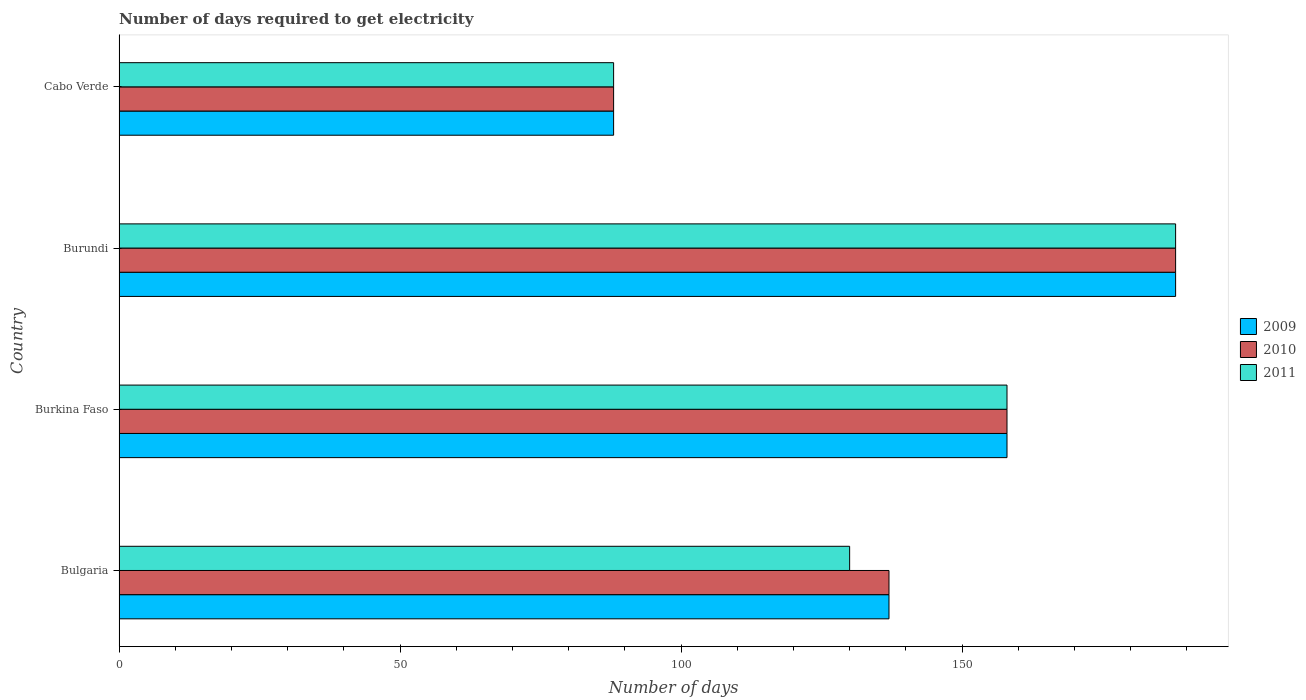How many different coloured bars are there?
Give a very brief answer. 3. What is the label of the 2nd group of bars from the top?
Your response must be concise. Burundi. What is the number of days required to get electricity in in 2010 in Burundi?
Your response must be concise. 188. Across all countries, what is the maximum number of days required to get electricity in in 2011?
Your answer should be compact. 188. Across all countries, what is the minimum number of days required to get electricity in in 2010?
Your answer should be compact. 88. In which country was the number of days required to get electricity in in 2009 maximum?
Make the answer very short. Burundi. In which country was the number of days required to get electricity in in 2011 minimum?
Provide a short and direct response. Cabo Verde. What is the total number of days required to get electricity in in 2009 in the graph?
Your answer should be very brief. 571. What is the difference between the number of days required to get electricity in in 2010 in Bulgaria and that in Cabo Verde?
Your response must be concise. 49. What is the average number of days required to get electricity in in 2011 per country?
Offer a very short reply. 141. What is the ratio of the number of days required to get electricity in in 2011 in Bulgaria to that in Cabo Verde?
Offer a very short reply. 1.48. What is the difference between the highest and the second highest number of days required to get electricity in in 2009?
Your answer should be compact. 30. What is the difference between the highest and the lowest number of days required to get electricity in in 2011?
Your answer should be compact. 100. Is the sum of the number of days required to get electricity in in 2011 in Burundi and Cabo Verde greater than the maximum number of days required to get electricity in in 2010 across all countries?
Provide a short and direct response. Yes. Is it the case that in every country, the sum of the number of days required to get electricity in in 2009 and number of days required to get electricity in in 2010 is greater than the number of days required to get electricity in in 2011?
Ensure brevity in your answer.  Yes. Are all the bars in the graph horizontal?
Ensure brevity in your answer.  Yes. How many countries are there in the graph?
Provide a succinct answer. 4. What is the difference between two consecutive major ticks on the X-axis?
Your answer should be compact. 50. Are the values on the major ticks of X-axis written in scientific E-notation?
Your answer should be very brief. No. Does the graph contain any zero values?
Your answer should be compact. No. Where does the legend appear in the graph?
Offer a terse response. Center right. How many legend labels are there?
Keep it short and to the point. 3. How are the legend labels stacked?
Give a very brief answer. Vertical. What is the title of the graph?
Your answer should be very brief. Number of days required to get electricity. What is the label or title of the X-axis?
Make the answer very short. Number of days. What is the label or title of the Y-axis?
Provide a short and direct response. Country. What is the Number of days of 2009 in Bulgaria?
Your answer should be very brief. 137. What is the Number of days of 2010 in Bulgaria?
Ensure brevity in your answer.  137. What is the Number of days in 2011 in Bulgaria?
Make the answer very short. 130. What is the Number of days in 2009 in Burkina Faso?
Your answer should be compact. 158. What is the Number of days of 2010 in Burkina Faso?
Ensure brevity in your answer.  158. What is the Number of days of 2011 in Burkina Faso?
Your answer should be compact. 158. What is the Number of days of 2009 in Burundi?
Your response must be concise. 188. What is the Number of days of 2010 in Burundi?
Provide a short and direct response. 188. What is the Number of days in 2011 in Burundi?
Give a very brief answer. 188. What is the Number of days in 2009 in Cabo Verde?
Provide a succinct answer. 88. What is the Number of days in 2010 in Cabo Verde?
Provide a short and direct response. 88. Across all countries, what is the maximum Number of days of 2009?
Offer a very short reply. 188. Across all countries, what is the maximum Number of days of 2010?
Provide a succinct answer. 188. Across all countries, what is the maximum Number of days of 2011?
Keep it short and to the point. 188. Across all countries, what is the minimum Number of days of 2010?
Offer a very short reply. 88. What is the total Number of days in 2009 in the graph?
Provide a short and direct response. 571. What is the total Number of days of 2010 in the graph?
Offer a terse response. 571. What is the total Number of days of 2011 in the graph?
Keep it short and to the point. 564. What is the difference between the Number of days in 2011 in Bulgaria and that in Burkina Faso?
Make the answer very short. -28. What is the difference between the Number of days in 2009 in Bulgaria and that in Burundi?
Provide a short and direct response. -51. What is the difference between the Number of days of 2010 in Bulgaria and that in Burundi?
Your answer should be very brief. -51. What is the difference between the Number of days of 2011 in Bulgaria and that in Burundi?
Give a very brief answer. -58. What is the difference between the Number of days in 2009 in Bulgaria and that in Cabo Verde?
Offer a very short reply. 49. What is the difference between the Number of days in 2010 in Bulgaria and that in Cabo Verde?
Offer a terse response. 49. What is the difference between the Number of days of 2009 in Burkina Faso and that in Burundi?
Your answer should be very brief. -30. What is the difference between the Number of days of 2009 in Burkina Faso and that in Cabo Verde?
Keep it short and to the point. 70. What is the difference between the Number of days in 2010 in Burkina Faso and that in Cabo Verde?
Your response must be concise. 70. What is the difference between the Number of days of 2009 in Burundi and that in Cabo Verde?
Provide a short and direct response. 100. What is the difference between the Number of days of 2009 in Bulgaria and the Number of days of 2011 in Burkina Faso?
Give a very brief answer. -21. What is the difference between the Number of days of 2010 in Bulgaria and the Number of days of 2011 in Burkina Faso?
Keep it short and to the point. -21. What is the difference between the Number of days in 2009 in Bulgaria and the Number of days in 2010 in Burundi?
Ensure brevity in your answer.  -51. What is the difference between the Number of days of 2009 in Bulgaria and the Number of days of 2011 in Burundi?
Offer a very short reply. -51. What is the difference between the Number of days in 2010 in Bulgaria and the Number of days in 2011 in Burundi?
Offer a terse response. -51. What is the difference between the Number of days in 2009 in Bulgaria and the Number of days in 2010 in Cabo Verde?
Make the answer very short. 49. What is the difference between the Number of days of 2009 in Bulgaria and the Number of days of 2011 in Cabo Verde?
Give a very brief answer. 49. What is the difference between the Number of days of 2010 in Bulgaria and the Number of days of 2011 in Cabo Verde?
Keep it short and to the point. 49. What is the difference between the Number of days in 2010 in Burkina Faso and the Number of days in 2011 in Burundi?
Offer a very short reply. -30. What is the difference between the Number of days in 2009 in Burkina Faso and the Number of days in 2010 in Cabo Verde?
Your answer should be compact. 70. What is the difference between the Number of days in 2009 in Burkina Faso and the Number of days in 2011 in Cabo Verde?
Your answer should be very brief. 70. What is the difference between the Number of days in 2010 in Burkina Faso and the Number of days in 2011 in Cabo Verde?
Give a very brief answer. 70. What is the difference between the Number of days in 2009 in Burundi and the Number of days in 2010 in Cabo Verde?
Keep it short and to the point. 100. What is the average Number of days of 2009 per country?
Provide a short and direct response. 142.75. What is the average Number of days in 2010 per country?
Provide a succinct answer. 142.75. What is the average Number of days in 2011 per country?
Your answer should be very brief. 141. What is the difference between the Number of days in 2010 and Number of days in 2011 in Bulgaria?
Your answer should be compact. 7. What is the difference between the Number of days of 2009 and Number of days of 2010 in Burkina Faso?
Offer a terse response. 0. What is the difference between the Number of days in 2009 and Number of days in 2011 in Burundi?
Ensure brevity in your answer.  0. What is the difference between the Number of days of 2010 and Number of days of 2011 in Burundi?
Make the answer very short. 0. What is the difference between the Number of days in 2009 and Number of days in 2010 in Cabo Verde?
Make the answer very short. 0. What is the difference between the Number of days of 2010 and Number of days of 2011 in Cabo Verde?
Keep it short and to the point. 0. What is the ratio of the Number of days in 2009 in Bulgaria to that in Burkina Faso?
Ensure brevity in your answer.  0.87. What is the ratio of the Number of days in 2010 in Bulgaria to that in Burkina Faso?
Your answer should be very brief. 0.87. What is the ratio of the Number of days in 2011 in Bulgaria to that in Burkina Faso?
Give a very brief answer. 0.82. What is the ratio of the Number of days in 2009 in Bulgaria to that in Burundi?
Provide a succinct answer. 0.73. What is the ratio of the Number of days in 2010 in Bulgaria to that in Burundi?
Ensure brevity in your answer.  0.73. What is the ratio of the Number of days of 2011 in Bulgaria to that in Burundi?
Make the answer very short. 0.69. What is the ratio of the Number of days in 2009 in Bulgaria to that in Cabo Verde?
Your answer should be very brief. 1.56. What is the ratio of the Number of days of 2010 in Bulgaria to that in Cabo Verde?
Provide a succinct answer. 1.56. What is the ratio of the Number of days of 2011 in Bulgaria to that in Cabo Verde?
Offer a very short reply. 1.48. What is the ratio of the Number of days in 2009 in Burkina Faso to that in Burundi?
Provide a succinct answer. 0.84. What is the ratio of the Number of days of 2010 in Burkina Faso to that in Burundi?
Provide a succinct answer. 0.84. What is the ratio of the Number of days of 2011 in Burkina Faso to that in Burundi?
Your answer should be compact. 0.84. What is the ratio of the Number of days in 2009 in Burkina Faso to that in Cabo Verde?
Your answer should be very brief. 1.8. What is the ratio of the Number of days of 2010 in Burkina Faso to that in Cabo Verde?
Make the answer very short. 1.8. What is the ratio of the Number of days in 2011 in Burkina Faso to that in Cabo Verde?
Provide a short and direct response. 1.8. What is the ratio of the Number of days of 2009 in Burundi to that in Cabo Verde?
Offer a very short reply. 2.14. What is the ratio of the Number of days of 2010 in Burundi to that in Cabo Verde?
Your answer should be compact. 2.14. What is the ratio of the Number of days of 2011 in Burundi to that in Cabo Verde?
Offer a very short reply. 2.14. What is the difference between the highest and the second highest Number of days in 2009?
Your answer should be very brief. 30. What is the difference between the highest and the second highest Number of days of 2010?
Offer a very short reply. 30. What is the difference between the highest and the second highest Number of days in 2011?
Your response must be concise. 30. What is the difference between the highest and the lowest Number of days in 2009?
Make the answer very short. 100. What is the difference between the highest and the lowest Number of days in 2010?
Provide a succinct answer. 100. What is the difference between the highest and the lowest Number of days in 2011?
Ensure brevity in your answer.  100. 